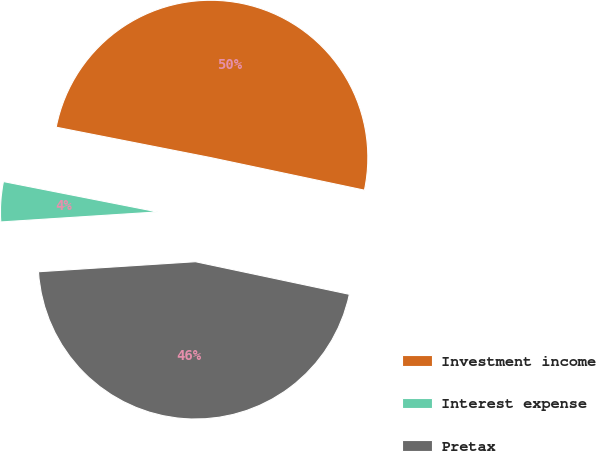<chart> <loc_0><loc_0><loc_500><loc_500><pie_chart><fcel>Investment income<fcel>Interest expense<fcel>Pretax<nl><fcel>50.23%<fcel>4.11%<fcel>45.66%<nl></chart> 